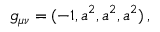<formula> <loc_0><loc_0><loc_500><loc_500>g _ { \mu \nu } = ( - 1 , a ^ { 2 } , a ^ { 2 } , a ^ { 2 } ) \, ,</formula> 